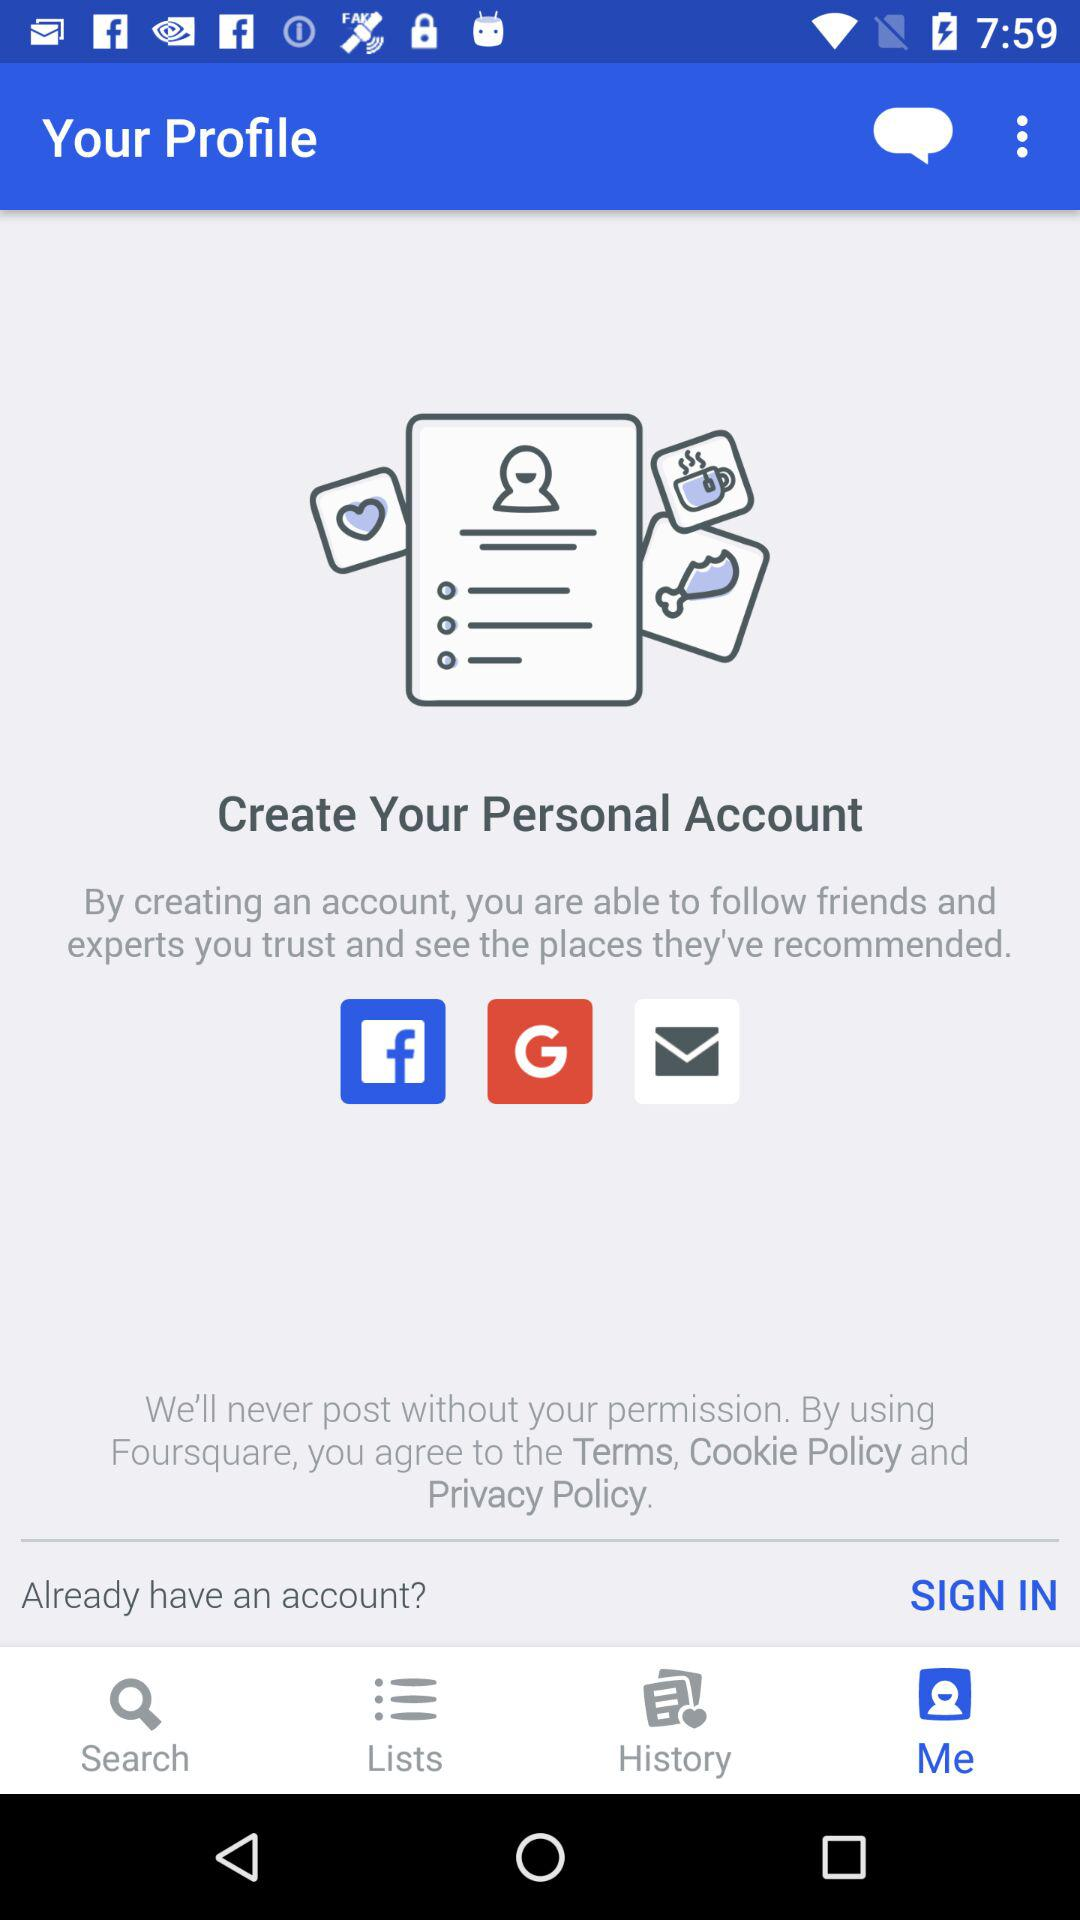What is the name of the application? The application name is "Foursquare". 